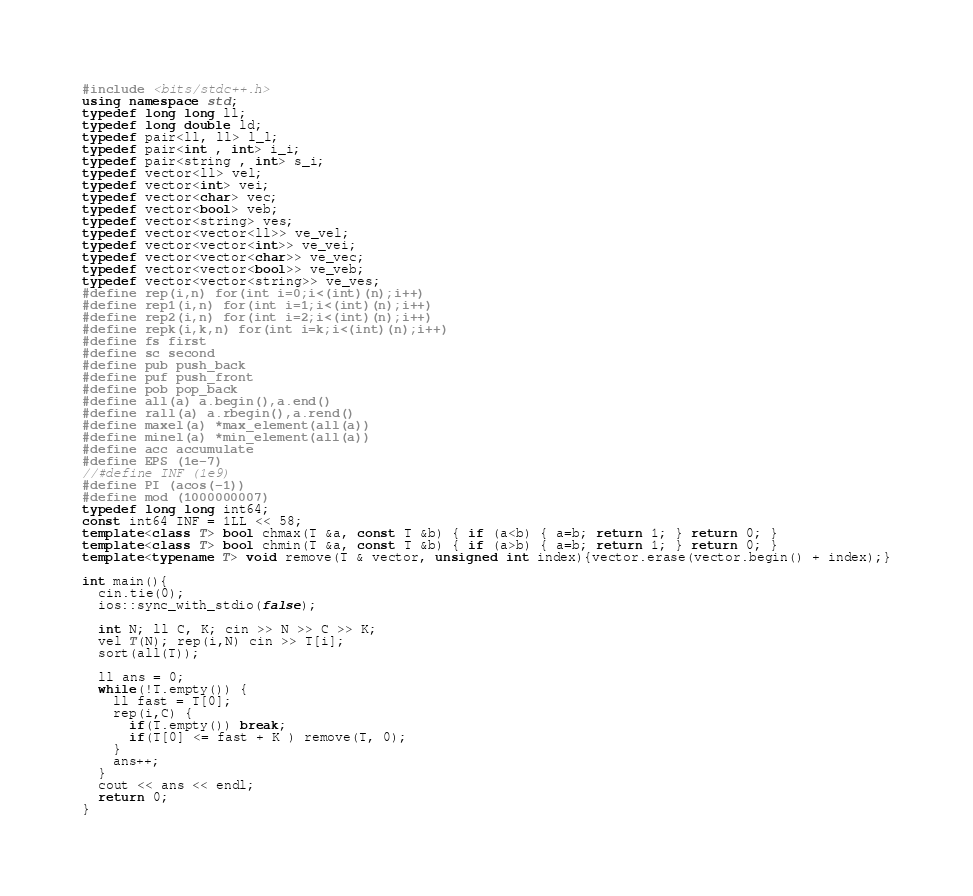Convert code to text. <code><loc_0><loc_0><loc_500><loc_500><_C++_>#include <bits/stdc++.h>
using namespace std;
typedef long long ll;
typedef long double ld;
typedef pair<ll, ll> l_l;
typedef pair<int , int> i_i;
typedef pair<string , int> s_i;
typedef vector<ll> vel;
typedef vector<int> vei;
typedef vector<char> vec;
typedef vector<bool> veb;
typedef vector<string> ves;
typedef vector<vector<ll>> ve_vel;
typedef vector<vector<int>> ve_vei;
typedef vector<vector<char>> ve_vec;
typedef vector<vector<bool>> ve_veb;
typedef vector<vector<string>> ve_ves;
#define rep(i,n) for(int i=0;i<(int)(n);i++)
#define rep1(i,n) for(int i=1;i<(int)(n);i++)
#define rep2(i,n) for(int i=2;i<(int)(n);i++)
#define repk(i,k,n) for(int i=k;i<(int)(n);i++)
#define fs first
#define sc second
#define pub push_back
#define puf push_front
#define pob pop_back
#define all(a) a.begin(),a.end()
#define rall(a) a.rbegin(),a.rend()
#define maxel(a) *max_element(all(a))
#define minel(a) *min_element(all(a))
#define acc accumulate
#define EPS (1e-7)
//#define INF (1e9)
#define PI (acos(-1))
#define mod (1000000007)
typedef long long int64;
const int64 INF = 1LL << 58;
template<class T> bool chmax(T &a, const T &b) { if (a<b) { a=b; return 1; } return 0; }
template<class T> bool chmin(T &a, const T &b) { if (a>b) { a=b; return 1; } return 0; }
template<typename T> void remove(T & vector, unsigned int index){vector.erase(vector.begin() + index);}

int main(){
  cin.tie(0);
  ios::sync_with_stdio(false);

  int N; ll C, K; cin >> N >> C >> K;
  vel T(N); rep(i,N) cin >> T[i];
  sort(all(T));
  
  ll ans = 0;
  while(!T.empty()) {
    ll fast = T[0];
    rep(i,C) {
      if(T.empty()) break;
      if(T[0] <= fast + K ) remove(T, 0);
    }
    ans++;
  }
  cout << ans << endl;
  return 0;
}</code> 